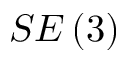<formula> <loc_0><loc_0><loc_500><loc_500>S E \left ( 3 \right )</formula> 